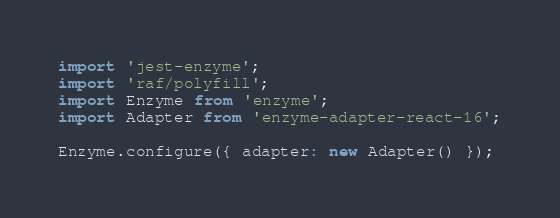Convert code to text. <code><loc_0><loc_0><loc_500><loc_500><_JavaScript_>import 'jest-enzyme';
import 'raf/polyfill';
import Enzyme from 'enzyme';
import Adapter from 'enzyme-adapter-react-16';

Enzyme.configure({ adapter: new Adapter() });
</code> 